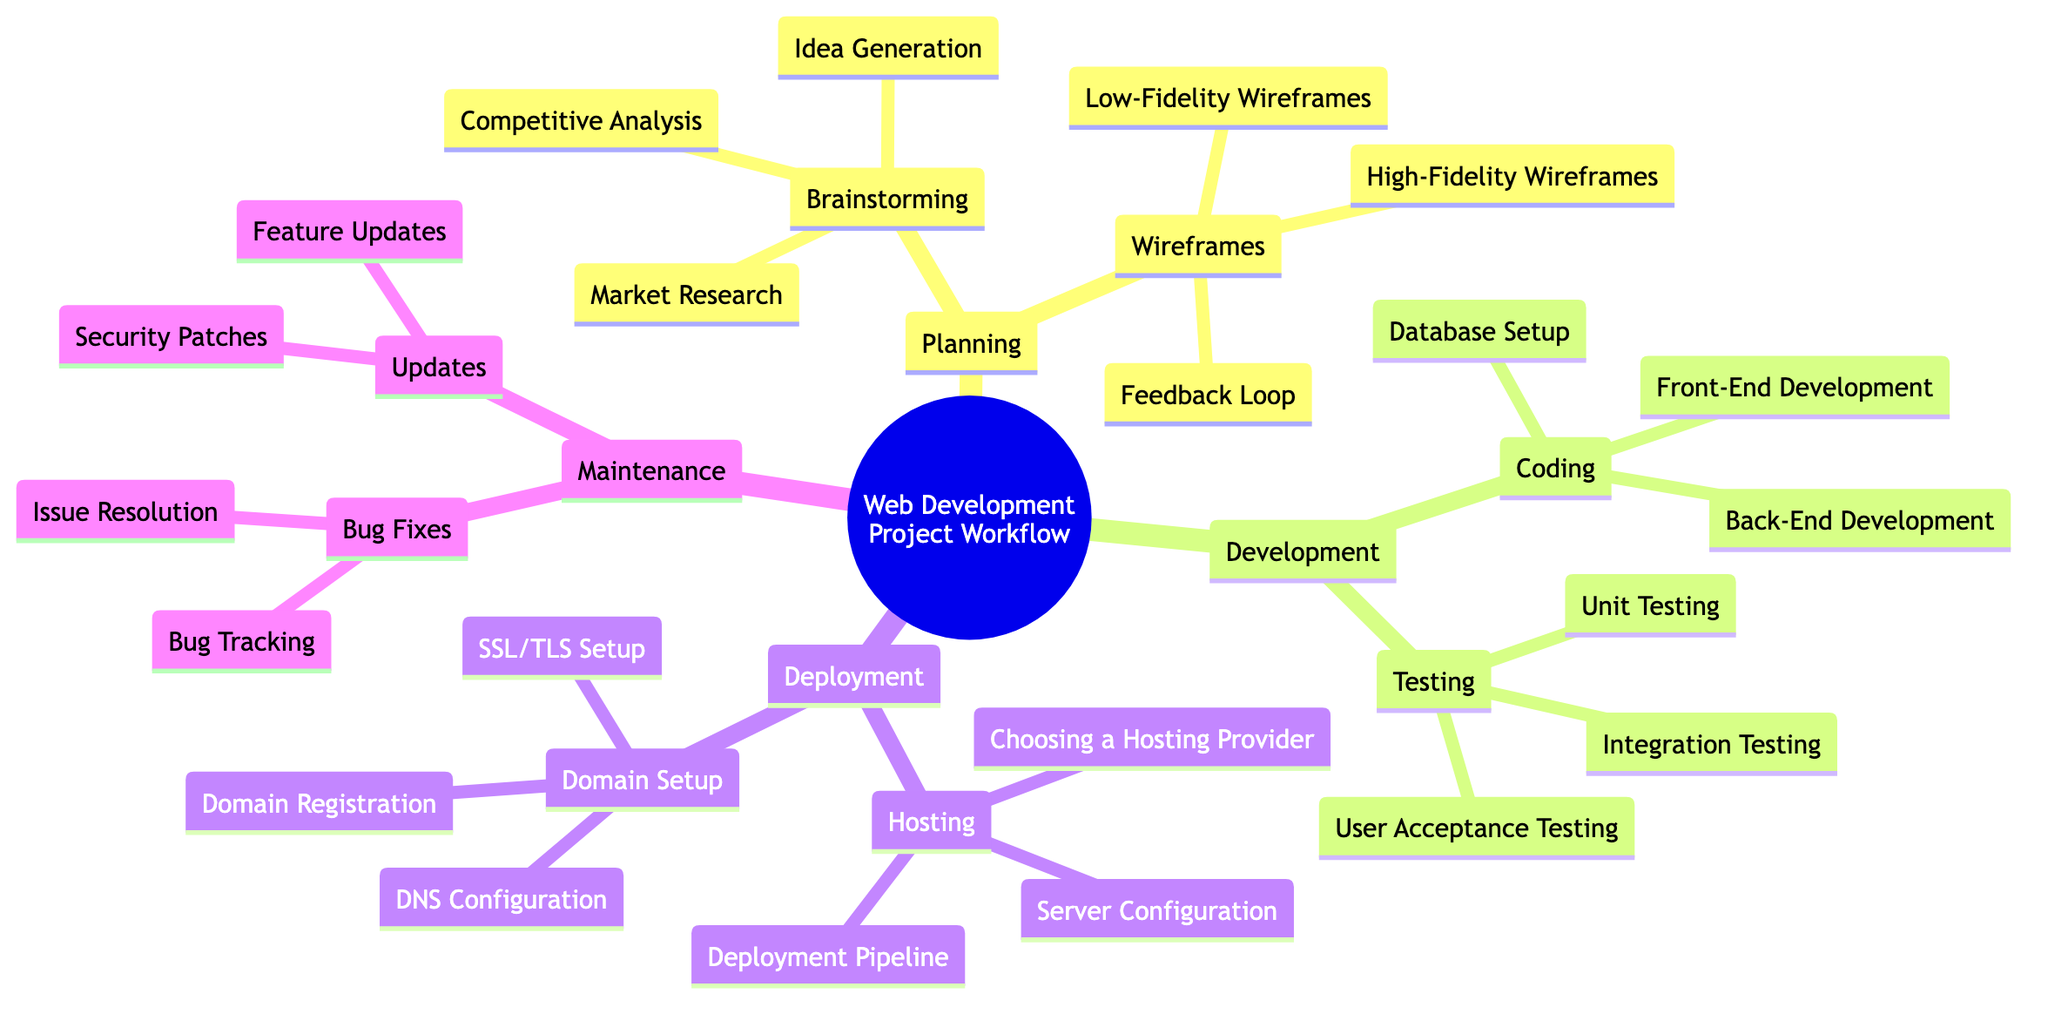What are the two main segments under "Development"? The "Development" section includes "Coding" and "Testing," which are both main activities involved in the process.
Answer: Coding, Testing How many types of wireframes are listed? The "Wireframes" section contains three types: "Low-Fidelity Wireframes," "High-Fidelity Wireframes," and "Feedback Loop," which totals three wireframe types.
Answer: 3 What is the first step in the "Deployment" phase? The first step listed in the "Deployment" section is "Hosting," which is broken into multiple sub-steps showing the focus on deployment aspects.
Answer: Hosting Which type of testing focuses on user feedback? "User Acceptance Testing" is identified as a type of testing that focuses directly on user feedback to validate the developed application.
Answer: User Acceptance Testing What comes after "Brainstorming"? Following the "Brainstorming" phase in "Planning," the next step is "Wireframes," indicating a progression from idea generation to structuring those ideas visually.
Answer: Wireframes List the two categories under "Maintenance." The "Maintenance" section comprises two categories: "Updates" and "Bug Fixes," highlighting ongoing needs after deployment.
Answer: Updates, Bug Fixes What focuses on the "Domain Setup" in deployment? The "Domain Setup" section details essential tasks including "Domain Registration," "DNS Configuration," and "SSL/TLS Setup," making it a critical focus for domain management.
Answer: Domain Registration, DNS Configuration, SSL/TLS Setup How many testing types are included in the "Testing" section? The "Testing" section lists three types: "Unit Testing," "Integration Testing," and "User Acceptance Testing," confirming a thorough approach to validating the application.
Answer: 3 What must be considered when choosing a hosting provider? The "Choosing a Hosting Provider" task under "Hosting" signifies the importance of evaluating different providers based on project needs and reliability before proceeding with the project.
Answer: Choosing a Hosting Provider 